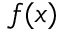<formula> <loc_0><loc_0><loc_500><loc_500>f ( x )</formula> 